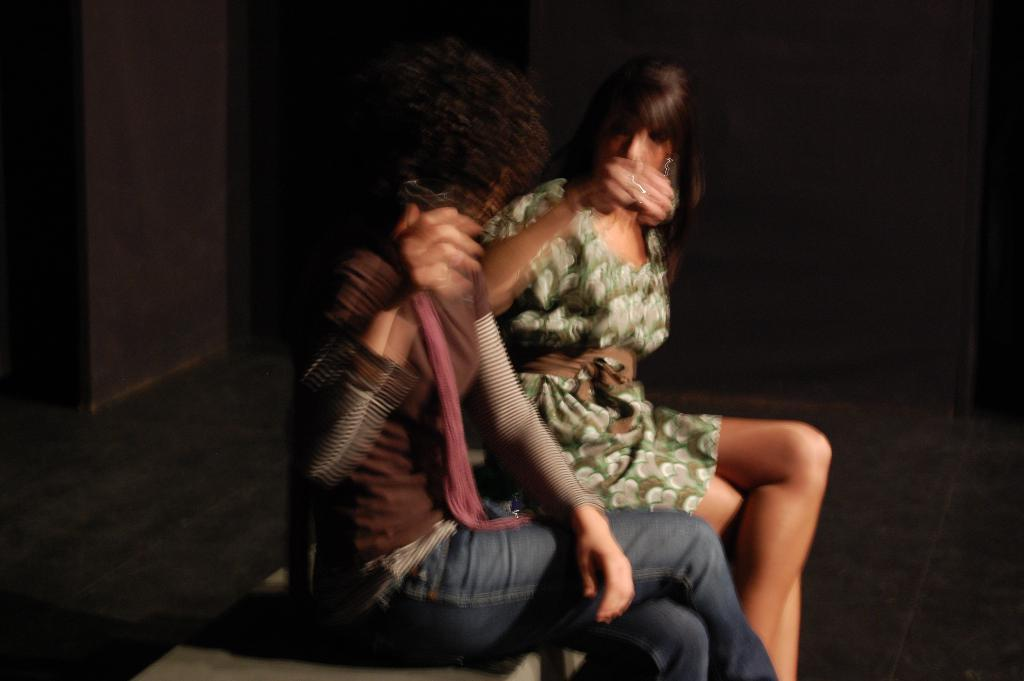How many people are in the image? There are two women in the image. What are the women doing in the image? The women are sitting on a table. What can be seen in the background of the image? There is a wall in the background of the image. What type of parcel is being delivered to the women in the image? There is no parcel present in the image; the women are simply sitting on a table. What flight number are the women waiting for in the image? There is no reference to a flight or waiting in the image; the women are sitting on a table. 